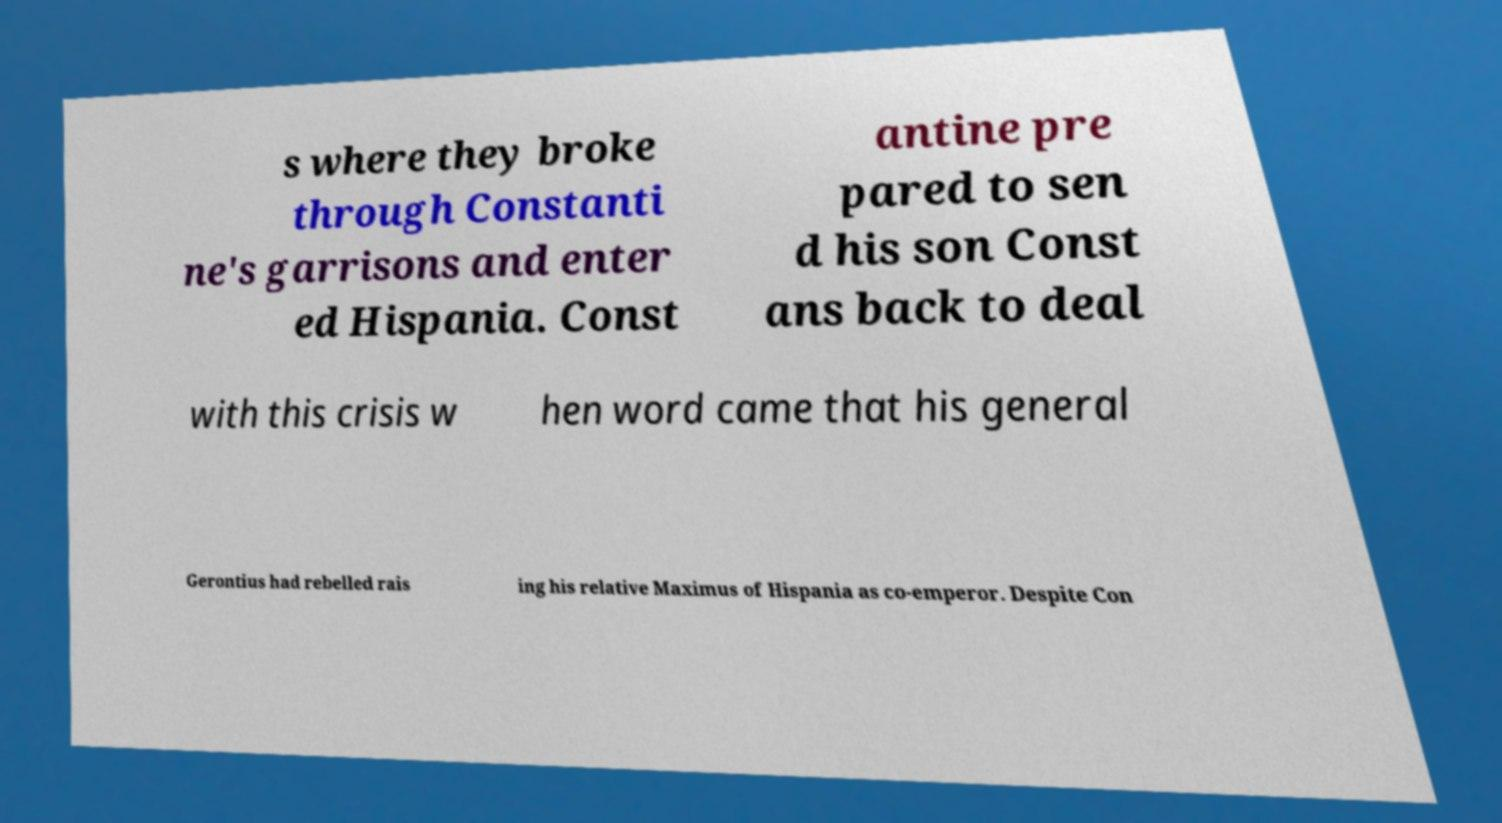Could you assist in decoding the text presented in this image and type it out clearly? s where they broke through Constanti ne's garrisons and enter ed Hispania. Const antine pre pared to sen d his son Const ans back to deal with this crisis w hen word came that his general Gerontius had rebelled rais ing his relative Maximus of Hispania as co-emperor. Despite Con 